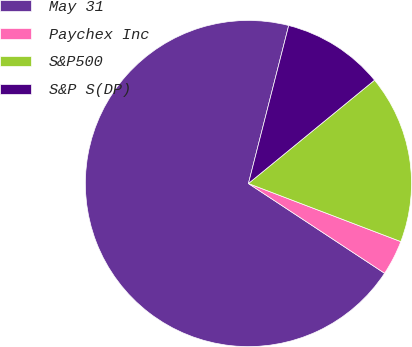<chart> <loc_0><loc_0><loc_500><loc_500><pie_chart><fcel>May 31<fcel>Paychex Inc<fcel>S&P500<fcel>S&P S(DP)<nl><fcel>69.69%<fcel>3.48%<fcel>16.72%<fcel>10.1%<nl></chart> 